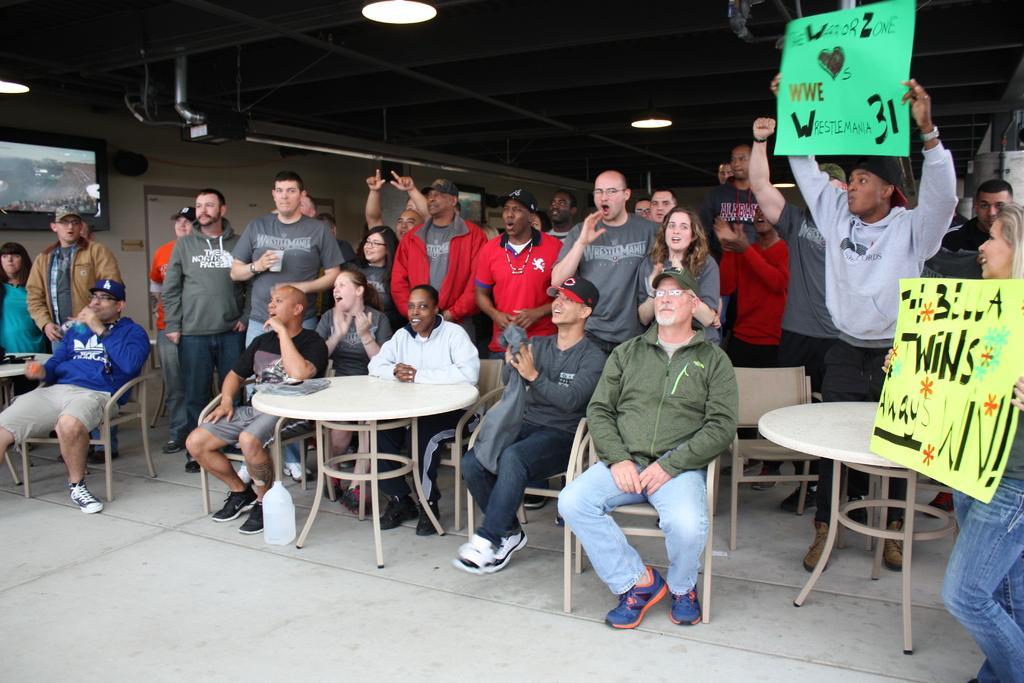In one or two sentences, can you explain what this image depicts? In this image I can see the group of people. Among them few people are sitting in-front of the table and few people are holding the papers. To the right there is a board attached to the wall. 